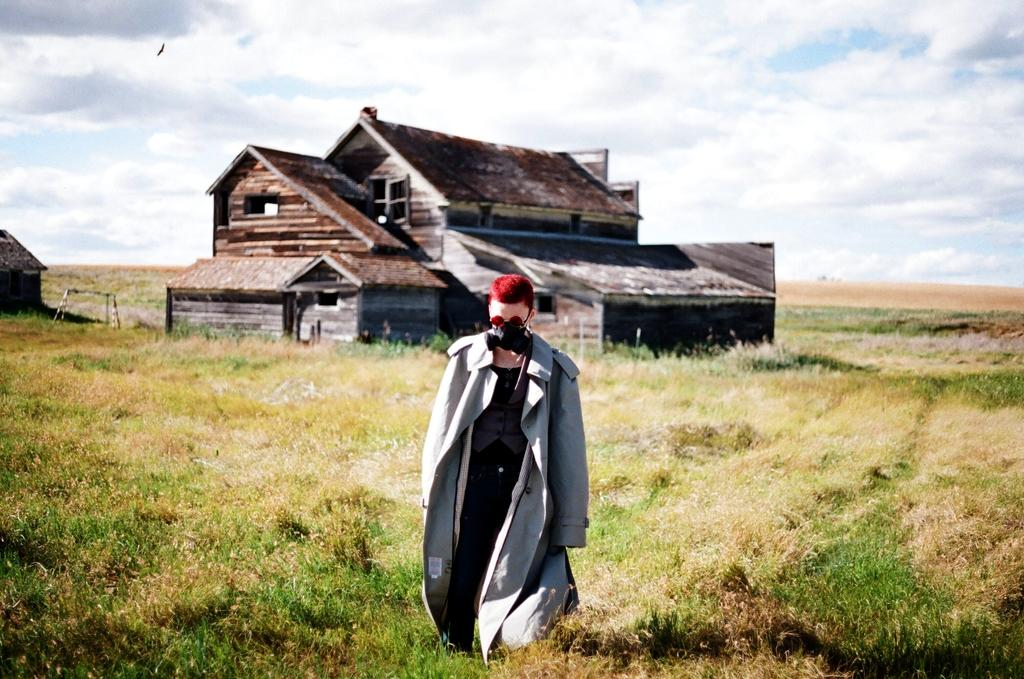Who or what is the main subject in the image? There is a person in the image. What type of surface is at the bottom of the image? Grass is present on the surface at the bottom of the image. What can be seen in the distance in the image? There are buildings in the background of the image. What is visible above the buildings in the image? The sky is visible in the background of the image. What type of ink is used for the caption in the image? There is no caption present in the image, so the type of ink cannot be determined. 